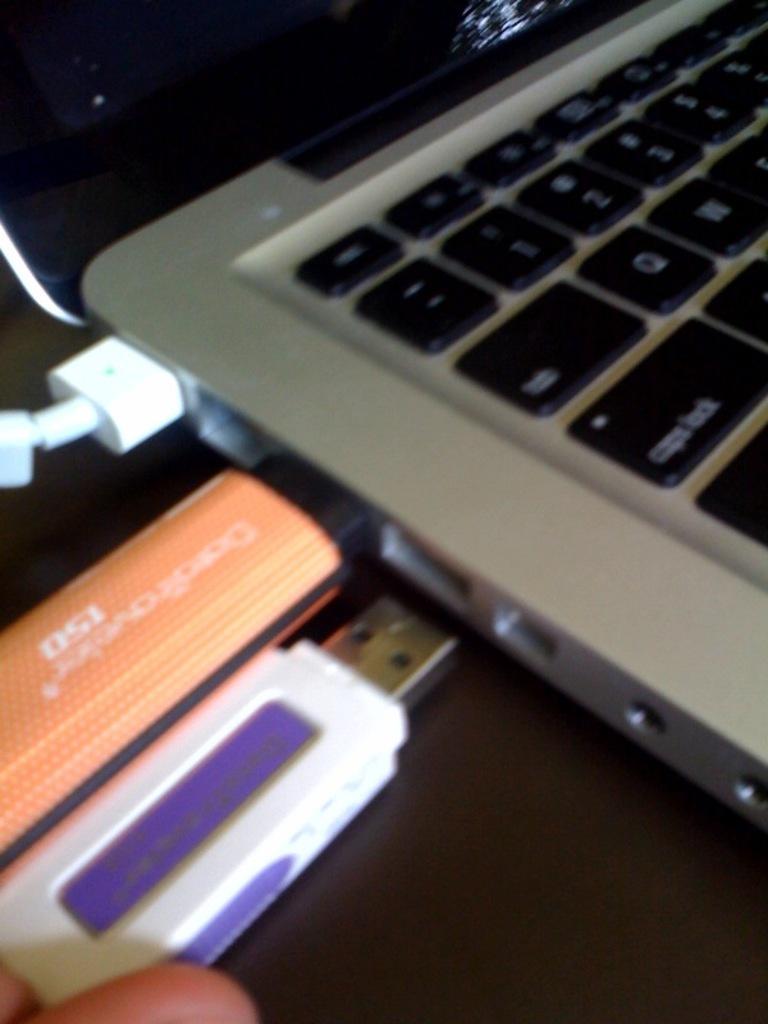Please provide a concise description of this image. In this picture I can see two pen drives and a cable are attached to a laptop, we can see a person finger holding a pen drive. 